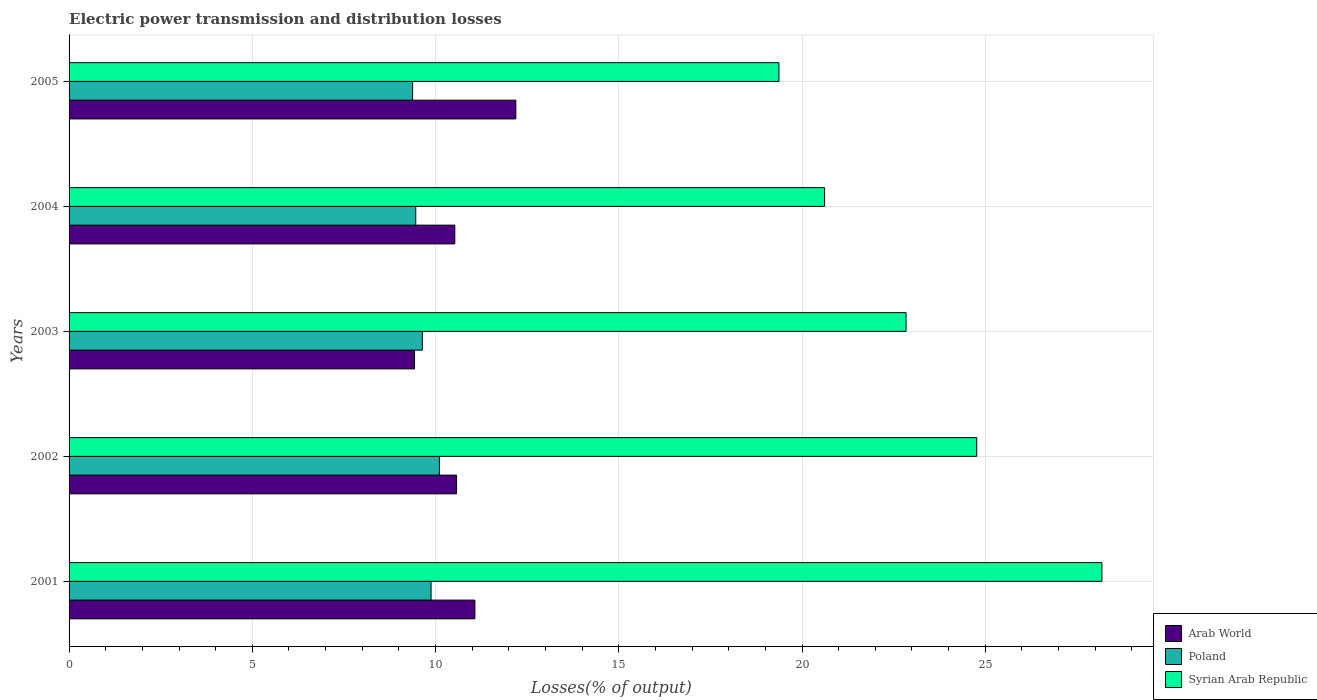How many different coloured bars are there?
Provide a short and direct response. 3. How many groups of bars are there?
Provide a short and direct response. 5. Are the number of bars per tick equal to the number of legend labels?
Provide a short and direct response. Yes. What is the label of the 1st group of bars from the top?
Your response must be concise. 2005. In how many cases, is the number of bars for a given year not equal to the number of legend labels?
Your answer should be very brief. 0. What is the electric power transmission and distribution losses in Arab World in 2001?
Offer a very short reply. 11.07. Across all years, what is the maximum electric power transmission and distribution losses in Arab World?
Make the answer very short. 12.19. Across all years, what is the minimum electric power transmission and distribution losses in Poland?
Give a very brief answer. 9.37. In which year was the electric power transmission and distribution losses in Syrian Arab Republic maximum?
Keep it short and to the point. 2001. What is the total electric power transmission and distribution losses in Syrian Arab Republic in the graph?
Provide a succinct answer. 115.77. What is the difference between the electric power transmission and distribution losses in Arab World in 2001 and that in 2002?
Make the answer very short. 0.5. What is the difference between the electric power transmission and distribution losses in Arab World in 2005 and the electric power transmission and distribution losses in Poland in 2003?
Provide a succinct answer. 2.55. What is the average electric power transmission and distribution losses in Arab World per year?
Your response must be concise. 10.76. In the year 2003, what is the difference between the electric power transmission and distribution losses in Syrian Arab Republic and electric power transmission and distribution losses in Arab World?
Offer a very short reply. 13.41. In how many years, is the electric power transmission and distribution losses in Poland greater than 21 %?
Make the answer very short. 0. What is the ratio of the electric power transmission and distribution losses in Poland in 2001 to that in 2005?
Provide a short and direct response. 1.05. What is the difference between the highest and the second highest electric power transmission and distribution losses in Syrian Arab Republic?
Offer a very short reply. 3.42. What is the difference between the highest and the lowest electric power transmission and distribution losses in Arab World?
Make the answer very short. 2.76. In how many years, is the electric power transmission and distribution losses in Syrian Arab Republic greater than the average electric power transmission and distribution losses in Syrian Arab Republic taken over all years?
Keep it short and to the point. 2. Is the sum of the electric power transmission and distribution losses in Syrian Arab Republic in 2002 and 2005 greater than the maximum electric power transmission and distribution losses in Poland across all years?
Offer a very short reply. Yes. What does the 2nd bar from the bottom in 2002 represents?
Keep it short and to the point. Poland. Is it the case that in every year, the sum of the electric power transmission and distribution losses in Syrian Arab Republic and electric power transmission and distribution losses in Arab World is greater than the electric power transmission and distribution losses in Poland?
Your answer should be compact. Yes. Are all the bars in the graph horizontal?
Provide a short and direct response. Yes. How many years are there in the graph?
Make the answer very short. 5. Does the graph contain grids?
Provide a succinct answer. Yes. Where does the legend appear in the graph?
Provide a succinct answer. Bottom right. What is the title of the graph?
Offer a terse response. Electric power transmission and distribution losses. Does "Isle of Man" appear as one of the legend labels in the graph?
Your response must be concise. No. What is the label or title of the X-axis?
Offer a very short reply. Losses(% of output). What is the Losses(% of output) of Arab World in 2001?
Provide a short and direct response. 11.07. What is the Losses(% of output) of Poland in 2001?
Offer a very short reply. 9.88. What is the Losses(% of output) of Syrian Arab Republic in 2001?
Your answer should be compact. 28.18. What is the Losses(% of output) of Arab World in 2002?
Keep it short and to the point. 10.57. What is the Losses(% of output) of Poland in 2002?
Offer a very short reply. 10.11. What is the Losses(% of output) in Syrian Arab Republic in 2002?
Provide a short and direct response. 24.77. What is the Losses(% of output) in Arab World in 2003?
Offer a very short reply. 9.43. What is the Losses(% of output) in Poland in 2003?
Offer a very short reply. 9.64. What is the Losses(% of output) in Syrian Arab Republic in 2003?
Give a very brief answer. 22.84. What is the Losses(% of output) in Arab World in 2004?
Give a very brief answer. 10.53. What is the Losses(% of output) in Poland in 2004?
Ensure brevity in your answer.  9.46. What is the Losses(% of output) of Syrian Arab Republic in 2004?
Your answer should be very brief. 20.62. What is the Losses(% of output) of Arab World in 2005?
Give a very brief answer. 12.19. What is the Losses(% of output) in Poland in 2005?
Offer a very short reply. 9.37. What is the Losses(% of output) in Syrian Arab Republic in 2005?
Your answer should be very brief. 19.37. Across all years, what is the maximum Losses(% of output) in Arab World?
Provide a succinct answer. 12.19. Across all years, what is the maximum Losses(% of output) in Poland?
Give a very brief answer. 10.11. Across all years, what is the maximum Losses(% of output) of Syrian Arab Republic?
Your answer should be compact. 28.18. Across all years, what is the minimum Losses(% of output) in Arab World?
Your answer should be very brief. 9.43. Across all years, what is the minimum Losses(% of output) in Poland?
Keep it short and to the point. 9.37. Across all years, what is the minimum Losses(% of output) of Syrian Arab Republic?
Provide a succinct answer. 19.37. What is the total Losses(% of output) in Arab World in the graph?
Your answer should be very brief. 53.79. What is the total Losses(% of output) in Poland in the graph?
Give a very brief answer. 48.46. What is the total Losses(% of output) of Syrian Arab Republic in the graph?
Your answer should be compact. 115.77. What is the difference between the Losses(% of output) of Arab World in 2001 and that in 2002?
Offer a terse response. 0.5. What is the difference between the Losses(% of output) in Poland in 2001 and that in 2002?
Make the answer very short. -0.23. What is the difference between the Losses(% of output) of Syrian Arab Republic in 2001 and that in 2002?
Your answer should be compact. 3.42. What is the difference between the Losses(% of output) in Arab World in 2001 and that in 2003?
Offer a terse response. 1.65. What is the difference between the Losses(% of output) in Poland in 2001 and that in 2003?
Offer a terse response. 0.24. What is the difference between the Losses(% of output) in Syrian Arab Republic in 2001 and that in 2003?
Provide a short and direct response. 5.34. What is the difference between the Losses(% of output) of Arab World in 2001 and that in 2004?
Your response must be concise. 0.55. What is the difference between the Losses(% of output) of Poland in 2001 and that in 2004?
Provide a short and direct response. 0.42. What is the difference between the Losses(% of output) of Syrian Arab Republic in 2001 and that in 2004?
Your response must be concise. 7.57. What is the difference between the Losses(% of output) of Arab World in 2001 and that in 2005?
Your answer should be compact. -1.12. What is the difference between the Losses(% of output) in Poland in 2001 and that in 2005?
Your response must be concise. 0.5. What is the difference between the Losses(% of output) of Syrian Arab Republic in 2001 and that in 2005?
Keep it short and to the point. 8.81. What is the difference between the Losses(% of output) of Arab World in 2002 and that in 2003?
Provide a succinct answer. 1.15. What is the difference between the Losses(% of output) in Poland in 2002 and that in 2003?
Offer a terse response. 0.47. What is the difference between the Losses(% of output) of Syrian Arab Republic in 2002 and that in 2003?
Keep it short and to the point. 1.93. What is the difference between the Losses(% of output) in Arab World in 2002 and that in 2004?
Make the answer very short. 0.05. What is the difference between the Losses(% of output) in Poland in 2002 and that in 2004?
Provide a short and direct response. 0.65. What is the difference between the Losses(% of output) in Syrian Arab Republic in 2002 and that in 2004?
Provide a short and direct response. 4.15. What is the difference between the Losses(% of output) of Arab World in 2002 and that in 2005?
Your answer should be compact. -1.62. What is the difference between the Losses(% of output) in Poland in 2002 and that in 2005?
Make the answer very short. 0.73. What is the difference between the Losses(% of output) in Syrian Arab Republic in 2002 and that in 2005?
Provide a succinct answer. 5.4. What is the difference between the Losses(% of output) in Arab World in 2003 and that in 2004?
Your response must be concise. -1.1. What is the difference between the Losses(% of output) of Poland in 2003 and that in 2004?
Keep it short and to the point. 0.18. What is the difference between the Losses(% of output) in Syrian Arab Republic in 2003 and that in 2004?
Provide a short and direct response. 2.22. What is the difference between the Losses(% of output) of Arab World in 2003 and that in 2005?
Offer a very short reply. -2.76. What is the difference between the Losses(% of output) in Poland in 2003 and that in 2005?
Provide a succinct answer. 0.27. What is the difference between the Losses(% of output) in Syrian Arab Republic in 2003 and that in 2005?
Your answer should be very brief. 3.47. What is the difference between the Losses(% of output) in Arab World in 2004 and that in 2005?
Make the answer very short. -1.66. What is the difference between the Losses(% of output) of Poland in 2004 and that in 2005?
Your response must be concise. 0.09. What is the difference between the Losses(% of output) of Syrian Arab Republic in 2004 and that in 2005?
Keep it short and to the point. 1.25. What is the difference between the Losses(% of output) of Arab World in 2001 and the Losses(% of output) of Poland in 2002?
Your answer should be compact. 0.97. What is the difference between the Losses(% of output) in Arab World in 2001 and the Losses(% of output) in Syrian Arab Republic in 2002?
Make the answer very short. -13.69. What is the difference between the Losses(% of output) in Poland in 2001 and the Losses(% of output) in Syrian Arab Republic in 2002?
Your answer should be compact. -14.89. What is the difference between the Losses(% of output) in Arab World in 2001 and the Losses(% of output) in Poland in 2003?
Make the answer very short. 1.43. What is the difference between the Losses(% of output) in Arab World in 2001 and the Losses(% of output) in Syrian Arab Republic in 2003?
Make the answer very short. -11.77. What is the difference between the Losses(% of output) in Poland in 2001 and the Losses(% of output) in Syrian Arab Republic in 2003?
Give a very brief answer. -12.96. What is the difference between the Losses(% of output) of Arab World in 2001 and the Losses(% of output) of Poland in 2004?
Your response must be concise. 1.61. What is the difference between the Losses(% of output) in Arab World in 2001 and the Losses(% of output) in Syrian Arab Republic in 2004?
Offer a very short reply. -9.54. What is the difference between the Losses(% of output) of Poland in 2001 and the Losses(% of output) of Syrian Arab Republic in 2004?
Offer a terse response. -10.74. What is the difference between the Losses(% of output) in Arab World in 2001 and the Losses(% of output) in Poland in 2005?
Give a very brief answer. 1.7. What is the difference between the Losses(% of output) of Arab World in 2001 and the Losses(% of output) of Syrian Arab Republic in 2005?
Your answer should be compact. -8.3. What is the difference between the Losses(% of output) in Poland in 2001 and the Losses(% of output) in Syrian Arab Republic in 2005?
Keep it short and to the point. -9.49. What is the difference between the Losses(% of output) of Arab World in 2002 and the Losses(% of output) of Poland in 2003?
Keep it short and to the point. 0.93. What is the difference between the Losses(% of output) of Arab World in 2002 and the Losses(% of output) of Syrian Arab Republic in 2003?
Offer a terse response. -12.27. What is the difference between the Losses(% of output) of Poland in 2002 and the Losses(% of output) of Syrian Arab Republic in 2003?
Your answer should be compact. -12.73. What is the difference between the Losses(% of output) of Arab World in 2002 and the Losses(% of output) of Poland in 2004?
Your answer should be compact. 1.11. What is the difference between the Losses(% of output) of Arab World in 2002 and the Losses(% of output) of Syrian Arab Republic in 2004?
Your response must be concise. -10.04. What is the difference between the Losses(% of output) of Poland in 2002 and the Losses(% of output) of Syrian Arab Republic in 2004?
Provide a succinct answer. -10.51. What is the difference between the Losses(% of output) in Arab World in 2002 and the Losses(% of output) in Poland in 2005?
Ensure brevity in your answer.  1.2. What is the difference between the Losses(% of output) in Arab World in 2002 and the Losses(% of output) in Syrian Arab Republic in 2005?
Provide a short and direct response. -8.8. What is the difference between the Losses(% of output) of Poland in 2002 and the Losses(% of output) of Syrian Arab Republic in 2005?
Your answer should be very brief. -9.26. What is the difference between the Losses(% of output) in Arab World in 2003 and the Losses(% of output) in Poland in 2004?
Your answer should be very brief. -0.03. What is the difference between the Losses(% of output) in Arab World in 2003 and the Losses(% of output) in Syrian Arab Republic in 2004?
Offer a terse response. -11.19. What is the difference between the Losses(% of output) in Poland in 2003 and the Losses(% of output) in Syrian Arab Republic in 2004?
Offer a terse response. -10.98. What is the difference between the Losses(% of output) of Arab World in 2003 and the Losses(% of output) of Poland in 2005?
Your response must be concise. 0.05. What is the difference between the Losses(% of output) in Arab World in 2003 and the Losses(% of output) in Syrian Arab Republic in 2005?
Give a very brief answer. -9.94. What is the difference between the Losses(% of output) in Poland in 2003 and the Losses(% of output) in Syrian Arab Republic in 2005?
Your answer should be compact. -9.73. What is the difference between the Losses(% of output) in Arab World in 2004 and the Losses(% of output) in Poland in 2005?
Provide a short and direct response. 1.15. What is the difference between the Losses(% of output) of Arab World in 2004 and the Losses(% of output) of Syrian Arab Republic in 2005?
Keep it short and to the point. -8.84. What is the difference between the Losses(% of output) of Poland in 2004 and the Losses(% of output) of Syrian Arab Republic in 2005?
Provide a short and direct response. -9.91. What is the average Losses(% of output) in Arab World per year?
Your answer should be compact. 10.76. What is the average Losses(% of output) of Poland per year?
Provide a succinct answer. 9.69. What is the average Losses(% of output) of Syrian Arab Republic per year?
Make the answer very short. 23.15. In the year 2001, what is the difference between the Losses(% of output) in Arab World and Losses(% of output) in Poland?
Ensure brevity in your answer.  1.2. In the year 2001, what is the difference between the Losses(% of output) in Arab World and Losses(% of output) in Syrian Arab Republic?
Give a very brief answer. -17.11. In the year 2001, what is the difference between the Losses(% of output) in Poland and Losses(% of output) in Syrian Arab Republic?
Your answer should be compact. -18.3. In the year 2002, what is the difference between the Losses(% of output) in Arab World and Losses(% of output) in Poland?
Your response must be concise. 0.47. In the year 2002, what is the difference between the Losses(% of output) in Arab World and Losses(% of output) in Syrian Arab Republic?
Provide a succinct answer. -14.19. In the year 2002, what is the difference between the Losses(% of output) of Poland and Losses(% of output) of Syrian Arab Republic?
Your answer should be compact. -14.66. In the year 2003, what is the difference between the Losses(% of output) of Arab World and Losses(% of output) of Poland?
Make the answer very short. -0.21. In the year 2003, what is the difference between the Losses(% of output) in Arab World and Losses(% of output) in Syrian Arab Republic?
Offer a terse response. -13.41. In the year 2003, what is the difference between the Losses(% of output) in Poland and Losses(% of output) in Syrian Arab Republic?
Keep it short and to the point. -13.2. In the year 2004, what is the difference between the Losses(% of output) of Arab World and Losses(% of output) of Poland?
Your response must be concise. 1.07. In the year 2004, what is the difference between the Losses(% of output) in Arab World and Losses(% of output) in Syrian Arab Republic?
Offer a very short reply. -10.09. In the year 2004, what is the difference between the Losses(% of output) in Poland and Losses(% of output) in Syrian Arab Republic?
Keep it short and to the point. -11.16. In the year 2005, what is the difference between the Losses(% of output) in Arab World and Losses(% of output) in Poland?
Ensure brevity in your answer.  2.82. In the year 2005, what is the difference between the Losses(% of output) in Arab World and Losses(% of output) in Syrian Arab Republic?
Your response must be concise. -7.18. In the year 2005, what is the difference between the Losses(% of output) of Poland and Losses(% of output) of Syrian Arab Republic?
Ensure brevity in your answer.  -10. What is the ratio of the Losses(% of output) in Arab World in 2001 to that in 2002?
Give a very brief answer. 1.05. What is the ratio of the Losses(% of output) of Poland in 2001 to that in 2002?
Offer a terse response. 0.98. What is the ratio of the Losses(% of output) in Syrian Arab Republic in 2001 to that in 2002?
Your answer should be compact. 1.14. What is the ratio of the Losses(% of output) in Arab World in 2001 to that in 2003?
Offer a very short reply. 1.17. What is the ratio of the Losses(% of output) in Poland in 2001 to that in 2003?
Offer a very short reply. 1.02. What is the ratio of the Losses(% of output) in Syrian Arab Republic in 2001 to that in 2003?
Make the answer very short. 1.23. What is the ratio of the Losses(% of output) of Arab World in 2001 to that in 2004?
Keep it short and to the point. 1.05. What is the ratio of the Losses(% of output) of Poland in 2001 to that in 2004?
Ensure brevity in your answer.  1.04. What is the ratio of the Losses(% of output) in Syrian Arab Republic in 2001 to that in 2004?
Provide a short and direct response. 1.37. What is the ratio of the Losses(% of output) of Arab World in 2001 to that in 2005?
Your answer should be compact. 0.91. What is the ratio of the Losses(% of output) in Poland in 2001 to that in 2005?
Give a very brief answer. 1.05. What is the ratio of the Losses(% of output) in Syrian Arab Republic in 2001 to that in 2005?
Your response must be concise. 1.45. What is the ratio of the Losses(% of output) of Arab World in 2002 to that in 2003?
Provide a short and direct response. 1.12. What is the ratio of the Losses(% of output) in Poland in 2002 to that in 2003?
Your answer should be compact. 1.05. What is the ratio of the Losses(% of output) of Syrian Arab Republic in 2002 to that in 2003?
Offer a terse response. 1.08. What is the ratio of the Losses(% of output) of Poland in 2002 to that in 2004?
Ensure brevity in your answer.  1.07. What is the ratio of the Losses(% of output) in Syrian Arab Republic in 2002 to that in 2004?
Keep it short and to the point. 1.2. What is the ratio of the Losses(% of output) of Arab World in 2002 to that in 2005?
Provide a short and direct response. 0.87. What is the ratio of the Losses(% of output) in Poland in 2002 to that in 2005?
Your response must be concise. 1.08. What is the ratio of the Losses(% of output) of Syrian Arab Republic in 2002 to that in 2005?
Your response must be concise. 1.28. What is the ratio of the Losses(% of output) of Arab World in 2003 to that in 2004?
Your answer should be very brief. 0.9. What is the ratio of the Losses(% of output) of Poland in 2003 to that in 2004?
Your answer should be compact. 1.02. What is the ratio of the Losses(% of output) of Syrian Arab Republic in 2003 to that in 2004?
Give a very brief answer. 1.11. What is the ratio of the Losses(% of output) in Arab World in 2003 to that in 2005?
Provide a succinct answer. 0.77. What is the ratio of the Losses(% of output) in Poland in 2003 to that in 2005?
Offer a very short reply. 1.03. What is the ratio of the Losses(% of output) of Syrian Arab Republic in 2003 to that in 2005?
Your answer should be compact. 1.18. What is the ratio of the Losses(% of output) in Arab World in 2004 to that in 2005?
Your response must be concise. 0.86. What is the ratio of the Losses(% of output) of Poland in 2004 to that in 2005?
Make the answer very short. 1.01. What is the ratio of the Losses(% of output) of Syrian Arab Republic in 2004 to that in 2005?
Your answer should be compact. 1.06. What is the difference between the highest and the second highest Losses(% of output) in Arab World?
Give a very brief answer. 1.12. What is the difference between the highest and the second highest Losses(% of output) of Poland?
Ensure brevity in your answer.  0.23. What is the difference between the highest and the second highest Losses(% of output) of Syrian Arab Republic?
Offer a terse response. 3.42. What is the difference between the highest and the lowest Losses(% of output) of Arab World?
Your answer should be compact. 2.76. What is the difference between the highest and the lowest Losses(% of output) in Poland?
Ensure brevity in your answer.  0.73. What is the difference between the highest and the lowest Losses(% of output) of Syrian Arab Republic?
Make the answer very short. 8.81. 